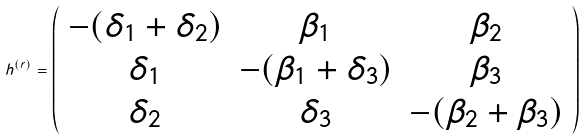<formula> <loc_0><loc_0><loc_500><loc_500>h ^ { ( r ) } = \left ( \begin{array} { c c c c } - ( \delta _ { 1 } + \delta _ { 2 } ) & \beta _ { 1 } & \beta _ { 2 } \\ \delta _ { 1 } & - ( \beta _ { 1 } + \delta _ { 3 } ) & \beta _ { 3 } \\ \delta _ { 2 } & \delta _ { 3 } & - ( \beta _ { 2 } + \beta _ { 3 } ) \end{array} \right )</formula> 